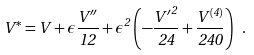<formula> <loc_0><loc_0><loc_500><loc_500>V ^ { * } = V + \epsilon \frac { V ^ { \prime \prime } } { 1 2 } + \epsilon ^ { 2 } \left ( - \frac { { V ^ { \prime } } ^ { 2 } } { 2 4 } + \frac { V ^ { ( 4 ) } } { 2 4 0 } \right ) \ .</formula> 